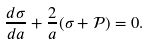<formula> <loc_0><loc_0><loc_500><loc_500>\frac { d \sigma } { d a } + \frac { 2 } { a } ( \sigma + \mathcal { P } ) = 0 .</formula> 